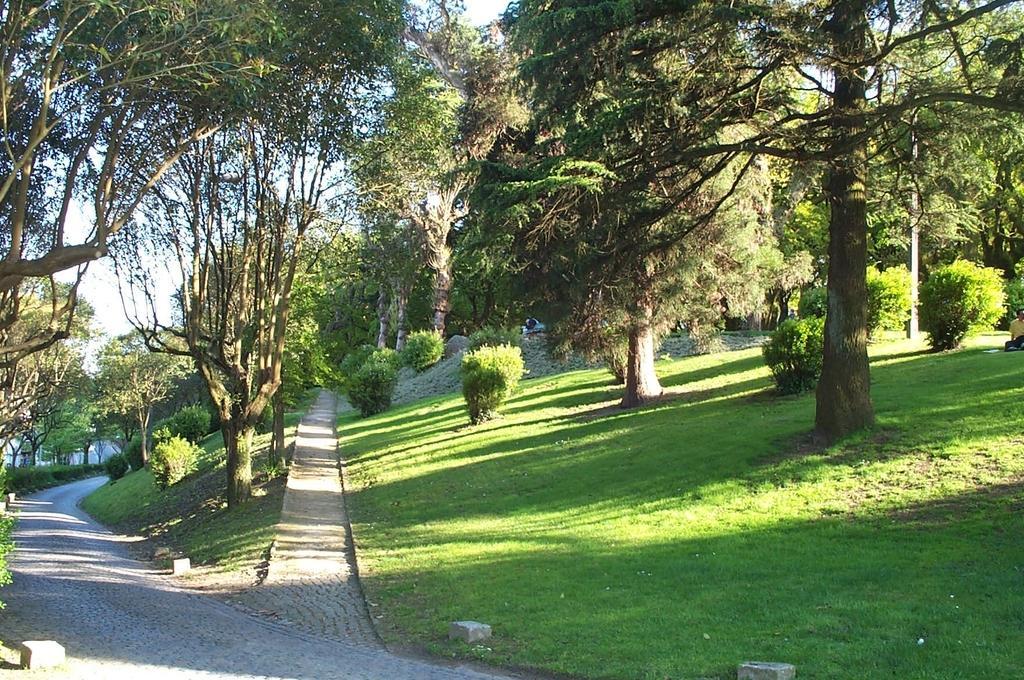Describe this image in one or two sentences. In this image I can see trees in green color and sky in white color. 